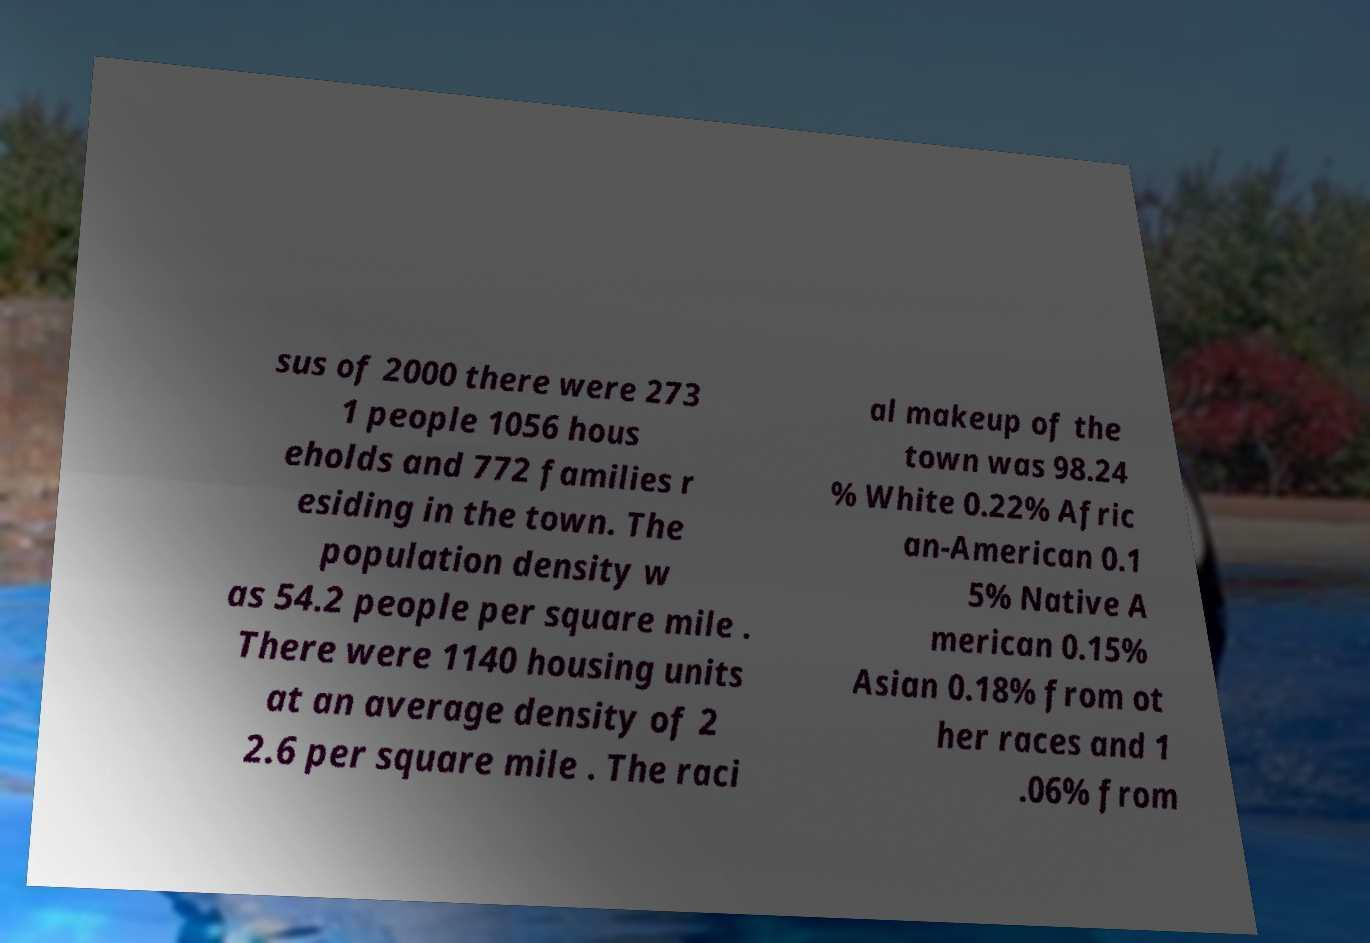Can you read and provide the text displayed in the image?This photo seems to have some interesting text. Can you extract and type it out for me? sus of 2000 there were 273 1 people 1056 hous eholds and 772 families r esiding in the town. The population density w as 54.2 people per square mile . There were 1140 housing units at an average density of 2 2.6 per square mile . The raci al makeup of the town was 98.24 % White 0.22% Afric an-American 0.1 5% Native A merican 0.15% Asian 0.18% from ot her races and 1 .06% from 